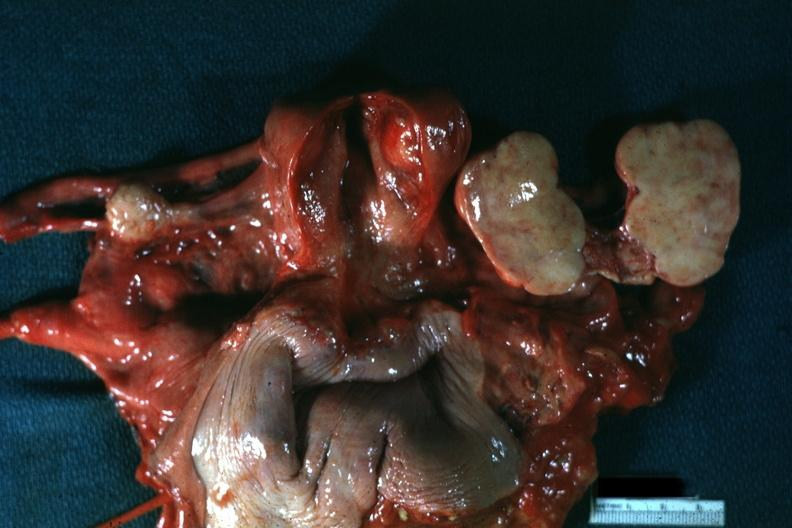what is present?
Answer the question using a single word or phrase. Thecoma 